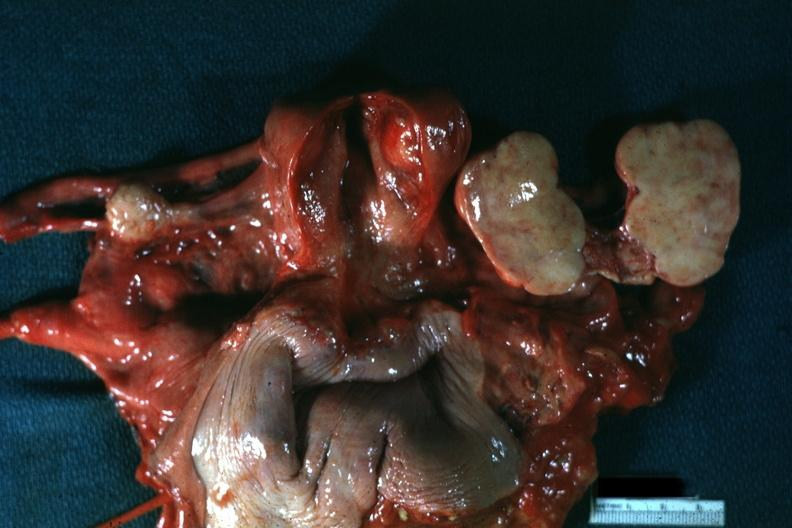what is present?
Answer the question using a single word or phrase. Thecoma 